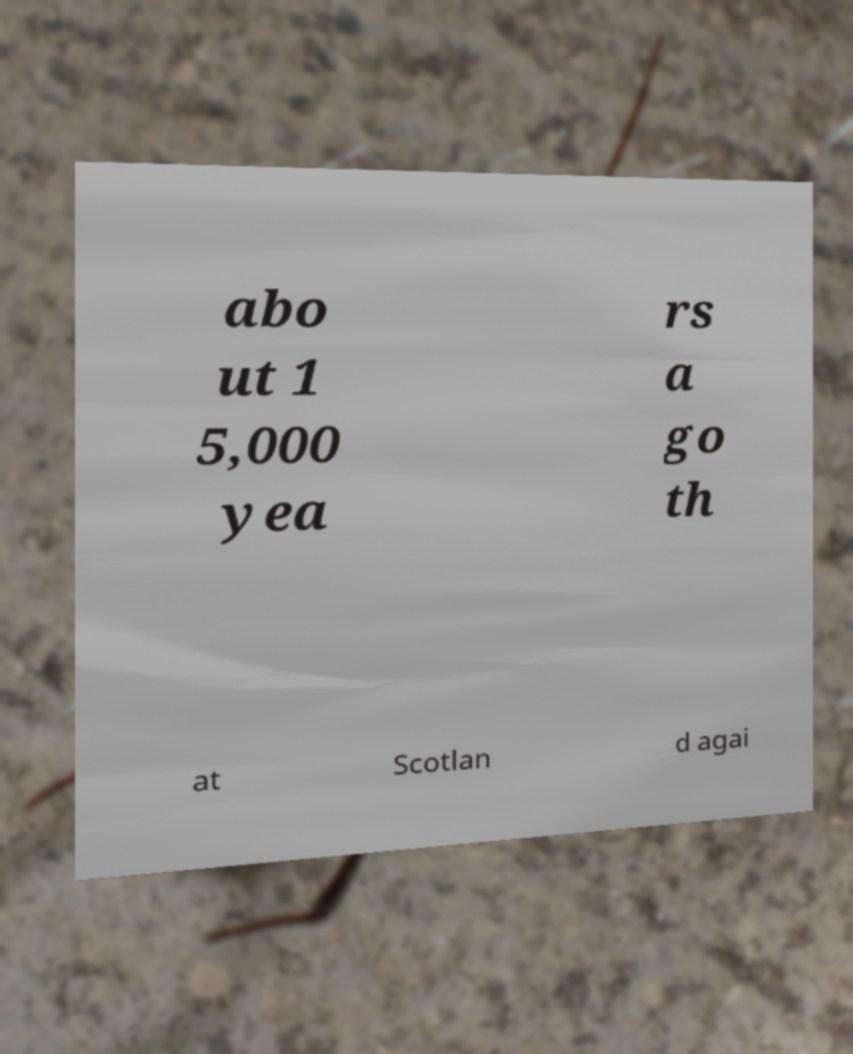Could you assist in decoding the text presented in this image and type it out clearly? abo ut 1 5,000 yea rs a go th at Scotlan d agai 